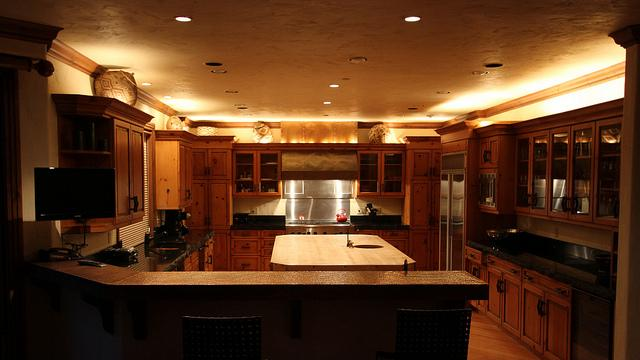What color is the water kettle on the top of the oven in the back of the kitchen?

Choices:
A) green
B) red
C) blue
D) yellow red 